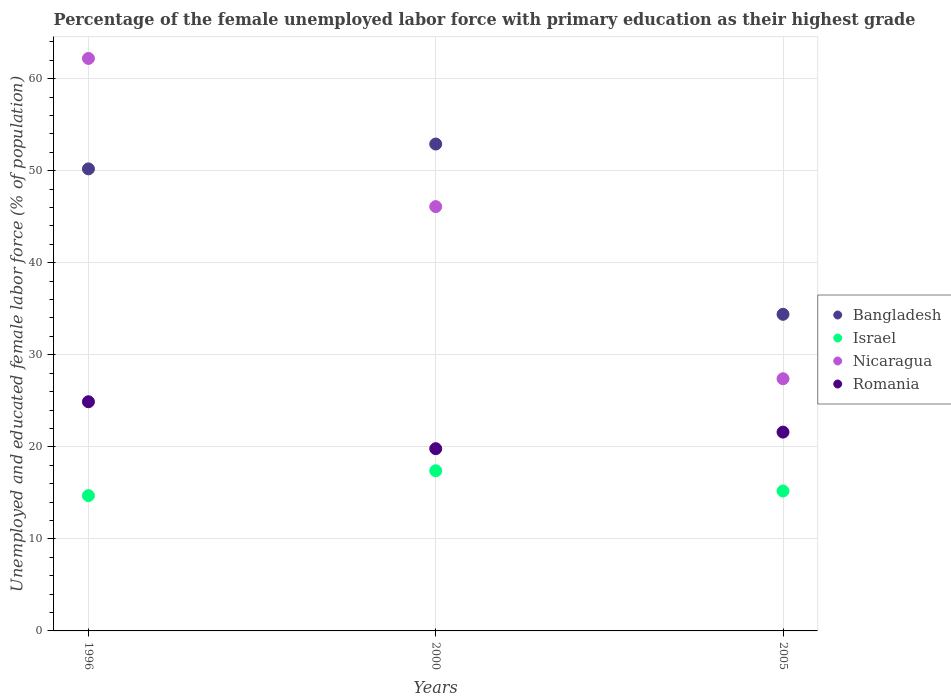Is the number of dotlines equal to the number of legend labels?
Offer a terse response. Yes. What is the percentage of the unemployed female labor force with primary education in Romania in 2005?
Your answer should be compact. 21.6. Across all years, what is the maximum percentage of the unemployed female labor force with primary education in Nicaragua?
Ensure brevity in your answer.  62.2. Across all years, what is the minimum percentage of the unemployed female labor force with primary education in Israel?
Give a very brief answer. 14.7. In which year was the percentage of the unemployed female labor force with primary education in Romania minimum?
Your answer should be compact. 2000. What is the total percentage of the unemployed female labor force with primary education in Israel in the graph?
Your response must be concise. 47.3. What is the difference between the percentage of the unemployed female labor force with primary education in Romania in 2000 and that in 2005?
Your answer should be very brief. -1.8. What is the difference between the percentage of the unemployed female labor force with primary education in Bangladesh in 2005 and the percentage of the unemployed female labor force with primary education in Nicaragua in 1996?
Make the answer very short. -27.8. What is the average percentage of the unemployed female labor force with primary education in Nicaragua per year?
Make the answer very short. 45.23. In the year 1996, what is the difference between the percentage of the unemployed female labor force with primary education in Israel and percentage of the unemployed female labor force with primary education in Romania?
Give a very brief answer. -10.2. What is the ratio of the percentage of the unemployed female labor force with primary education in Romania in 1996 to that in 2000?
Provide a succinct answer. 1.26. Is the percentage of the unemployed female labor force with primary education in Israel in 2000 less than that in 2005?
Your response must be concise. No. What is the difference between the highest and the second highest percentage of the unemployed female labor force with primary education in Bangladesh?
Give a very brief answer. 2.7. What is the difference between the highest and the lowest percentage of the unemployed female labor force with primary education in Israel?
Offer a terse response. 2.7. Is the sum of the percentage of the unemployed female labor force with primary education in Romania in 2000 and 2005 greater than the maximum percentage of the unemployed female labor force with primary education in Bangladesh across all years?
Make the answer very short. No. Is it the case that in every year, the sum of the percentage of the unemployed female labor force with primary education in Romania and percentage of the unemployed female labor force with primary education in Israel  is greater than the sum of percentage of the unemployed female labor force with primary education in Nicaragua and percentage of the unemployed female labor force with primary education in Bangladesh?
Offer a terse response. No. Is it the case that in every year, the sum of the percentage of the unemployed female labor force with primary education in Romania and percentage of the unemployed female labor force with primary education in Bangladesh  is greater than the percentage of the unemployed female labor force with primary education in Israel?
Provide a succinct answer. Yes. Is the percentage of the unemployed female labor force with primary education in Nicaragua strictly greater than the percentage of the unemployed female labor force with primary education in Romania over the years?
Give a very brief answer. Yes. Is the percentage of the unemployed female labor force with primary education in Bangladesh strictly less than the percentage of the unemployed female labor force with primary education in Israel over the years?
Give a very brief answer. No. What is the difference between two consecutive major ticks on the Y-axis?
Your answer should be very brief. 10. Does the graph contain grids?
Your response must be concise. Yes. Where does the legend appear in the graph?
Provide a succinct answer. Center right. How many legend labels are there?
Ensure brevity in your answer.  4. How are the legend labels stacked?
Offer a terse response. Vertical. What is the title of the graph?
Provide a succinct answer. Percentage of the female unemployed labor force with primary education as their highest grade. Does "Cyprus" appear as one of the legend labels in the graph?
Offer a very short reply. No. What is the label or title of the X-axis?
Your response must be concise. Years. What is the label or title of the Y-axis?
Your answer should be compact. Unemployed and educated female labor force (% of population). What is the Unemployed and educated female labor force (% of population) in Bangladesh in 1996?
Your answer should be compact. 50.2. What is the Unemployed and educated female labor force (% of population) of Israel in 1996?
Provide a succinct answer. 14.7. What is the Unemployed and educated female labor force (% of population) in Nicaragua in 1996?
Make the answer very short. 62.2. What is the Unemployed and educated female labor force (% of population) of Romania in 1996?
Keep it short and to the point. 24.9. What is the Unemployed and educated female labor force (% of population) in Bangladesh in 2000?
Your answer should be compact. 52.9. What is the Unemployed and educated female labor force (% of population) in Israel in 2000?
Provide a succinct answer. 17.4. What is the Unemployed and educated female labor force (% of population) in Nicaragua in 2000?
Your answer should be compact. 46.1. What is the Unemployed and educated female labor force (% of population) of Romania in 2000?
Give a very brief answer. 19.8. What is the Unemployed and educated female labor force (% of population) in Bangladesh in 2005?
Keep it short and to the point. 34.4. What is the Unemployed and educated female labor force (% of population) in Israel in 2005?
Provide a short and direct response. 15.2. What is the Unemployed and educated female labor force (% of population) of Nicaragua in 2005?
Your answer should be very brief. 27.4. What is the Unemployed and educated female labor force (% of population) of Romania in 2005?
Make the answer very short. 21.6. Across all years, what is the maximum Unemployed and educated female labor force (% of population) of Bangladesh?
Offer a terse response. 52.9. Across all years, what is the maximum Unemployed and educated female labor force (% of population) in Israel?
Make the answer very short. 17.4. Across all years, what is the maximum Unemployed and educated female labor force (% of population) of Nicaragua?
Your response must be concise. 62.2. Across all years, what is the maximum Unemployed and educated female labor force (% of population) of Romania?
Ensure brevity in your answer.  24.9. Across all years, what is the minimum Unemployed and educated female labor force (% of population) in Bangladesh?
Make the answer very short. 34.4. Across all years, what is the minimum Unemployed and educated female labor force (% of population) of Israel?
Your response must be concise. 14.7. Across all years, what is the minimum Unemployed and educated female labor force (% of population) of Nicaragua?
Keep it short and to the point. 27.4. Across all years, what is the minimum Unemployed and educated female labor force (% of population) in Romania?
Keep it short and to the point. 19.8. What is the total Unemployed and educated female labor force (% of population) of Bangladesh in the graph?
Make the answer very short. 137.5. What is the total Unemployed and educated female labor force (% of population) of Israel in the graph?
Your answer should be very brief. 47.3. What is the total Unemployed and educated female labor force (% of population) of Nicaragua in the graph?
Your answer should be very brief. 135.7. What is the total Unemployed and educated female labor force (% of population) of Romania in the graph?
Make the answer very short. 66.3. What is the difference between the Unemployed and educated female labor force (% of population) of Romania in 1996 and that in 2000?
Make the answer very short. 5.1. What is the difference between the Unemployed and educated female labor force (% of population) of Bangladesh in 1996 and that in 2005?
Your answer should be compact. 15.8. What is the difference between the Unemployed and educated female labor force (% of population) in Israel in 1996 and that in 2005?
Your answer should be compact. -0.5. What is the difference between the Unemployed and educated female labor force (% of population) in Nicaragua in 1996 and that in 2005?
Your answer should be compact. 34.8. What is the difference between the Unemployed and educated female labor force (% of population) of Romania in 1996 and that in 2005?
Provide a succinct answer. 3.3. What is the difference between the Unemployed and educated female labor force (% of population) in Bangladesh in 2000 and that in 2005?
Provide a succinct answer. 18.5. What is the difference between the Unemployed and educated female labor force (% of population) in Nicaragua in 2000 and that in 2005?
Your response must be concise. 18.7. What is the difference between the Unemployed and educated female labor force (% of population) of Romania in 2000 and that in 2005?
Your answer should be very brief. -1.8. What is the difference between the Unemployed and educated female labor force (% of population) of Bangladesh in 1996 and the Unemployed and educated female labor force (% of population) of Israel in 2000?
Offer a very short reply. 32.8. What is the difference between the Unemployed and educated female labor force (% of population) in Bangladesh in 1996 and the Unemployed and educated female labor force (% of population) in Nicaragua in 2000?
Keep it short and to the point. 4.1. What is the difference between the Unemployed and educated female labor force (% of population) of Bangladesh in 1996 and the Unemployed and educated female labor force (% of population) of Romania in 2000?
Your answer should be compact. 30.4. What is the difference between the Unemployed and educated female labor force (% of population) in Israel in 1996 and the Unemployed and educated female labor force (% of population) in Nicaragua in 2000?
Ensure brevity in your answer.  -31.4. What is the difference between the Unemployed and educated female labor force (% of population) of Nicaragua in 1996 and the Unemployed and educated female labor force (% of population) of Romania in 2000?
Offer a very short reply. 42.4. What is the difference between the Unemployed and educated female labor force (% of population) of Bangladesh in 1996 and the Unemployed and educated female labor force (% of population) of Nicaragua in 2005?
Keep it short and to the point. 22.8. What is the difference between the Unemployed and educated female labor force (% of population) of Bangladesh in 1996 and the Unemployed and educated female labor force (% of population) of Romania in 2005?
Ensure brevity in your answer.  28.6. What is the difference between the Unemployed and educated female labor force (% of population) of Israel in 1996 and the Unemployed and educated female labor force (% of population) of Nicaragua in 2005?
Your response must be concise. -12.7. What is the difference between the Unemployed and educated female labor force (% of population) in Nicaragua in 1996 and the Unemployed and educated female labor force (% of population) in Romania in 2005?
Offer a terse response. 40.6. What is the difference between the Unemployed and educated female labor force (% of population) in Bangladesh in 2000 and the Unemployed and educated female labor force (% of population) in Israel in 2005?
Offer a very short reply. 37.7. What is the difference between the Unemployed and educated female labor force (% of population) of Bangladesh in 2000 and the Unemployed and educated female labor force (% of population) of Nicaragua in 2005?
Make the answer very short. 25.5. What is the difference between the Unemployed and educated female labor force (% of population) in Bangladesh in 2000 and the Unemployed and educated female labor force (% of population) in Romania in 2005?
Ensure brevity in your answer.  31.3. What is the difference between the Unemployed and educated female labor force (% of population) of Israel in 2000 and the Unemployed and educated female labor force (% of population) of Nicaragua in 2005?
Provide a short and direct response. -10. What is the average Unemployed and educated female labor force (% of population) of Bangladesh per year?
Keep it short and to the point. 45.83. What is the average Unemployed and educated female labor force (% of population) of Israel per year?
Your answer should be compact. 15.77. What is the average Unemployed and educated female labor force (% of population) in Nicaragua per year?
Your answer should be very brief. 45.23. What is the average Unemployed and educated female labor force (% of population) in Romania per year?
Keep it short and to the point. 22.1. In the year 1996, what is the difference between the Unemployed and educated female labor force (% of population) in Bangladesh and Unemployed and educated female labor force (% of population) in Israel?
Provide a short and direct response. 35.5. In the year 1996, what is the difference between the Unemployed and educated female labor force (% of population) of Bangladesh and Unemployed and educated female labor force (% of population) of Romania?
Your answer should be very brief. 25.3. In the year 1996, what is the difference between the Unemployed and educated female labor force (% of population) in Israel and Unemployed and educated female labor force (% of population) in Nicaragua?
Keep it short and to the point. -47.5. In the year 1996, what is the difference between the Unemployed and educated female labor force (% of population) in Israel and Unemployed and educated female labor force (% of population) in Romania?
Offer a very short reply. -10.2. In the year 1996, what is the difference between the Unemployed and educated female labor force (% of population) of Nicaragua and Unemployed and educated female labor force (% of population) of Romania?
Keep it short and to the point. 37.3. In the year 2000, what is the difference between the Unemployed and educated female labor force (% of population) in Bangladesh and Unemployed and educated female labor force (% of population) in Israel?
Ensure brevity in your answer.  35.5. In the year 2000, what is the difference between the Unemployed and educated female labor force (% of population) of Bangladesh and Unemployed and educated female labor force (% of population) of Nicaragua?
Ensure brevity in your answer.  6.8. In the year 2000, what is the difference between the Unemployed and educated female labor force (% of population) of Bangladesh and Unemployed and educated female labor force (% of population) of Romania?
Make the answer very short. 33.1. In the year 2000, what is the difference between the Unemployed and educated female labor force (% of population) in Israel and Unemployed and educated female labor force (% of population) in Nicaragua?
Keep it short and to the point. -28.7. In the year 2000, what is the difference between the Unemployed and educated female labor force (% of population) in Nicaragua and Unemployed and educated female labor force (% of population) in Romania?
Provide a short and direct response. 26.3. In the year 2005, what is the difference between the Unemployed and educated female labor force (% of population) in Israel and Unemployed and educated female labor force (% of population) in Nicaragua?
Provide a succinct answer. -12.2. In the year 2005, what is the difference between the Unemployed and educated female labor force (% of population) in Israel and Unemployed and educated female labor force (% of population) in Romania?
Give a very brief answer. -6.4. What is the ratio of the Unemployed and educated female labor force (% of population) of Bangladesh in 1996 to that in 2000?
Offer a terse response. 0.95. What is the ratio of the Unemployed and educated female labor force (% of population) of Israel in 1996 to that in 2000?
Provide a short and direct response. 0.84. What is the ratio of the Unemployed and educated female labor force (% of population) in Nicaragua in 1996 to that in 2000?
Ensure brevity in your answer.  1.35. What is the ratio of the Unemployed and educated female labor force (% of population) of Romania in 1996 to that in 2000?
Provide a short and direct response. 1.26. What is the ratio of the Unemployed and educated female labor force (% of population) in Bangladesh in 1996 to that in 2005?
Offer a terse response. 1.46. What is the ratio of the Unemployed and educated female labor force (% of population) in Israel in 1996 to that in 2005?
Ensure brevity in your answer.  0.97. What is the ratio of the Unemployed and educated female labor force (% of population) in Nicaragua in 1996 to that in 2005?
Your answer should be compact. 2.27. What is the ratio of the Unemployed and educated female labor force (% of population) in Romania in 1996 to that in 2005?
Provide a short and direct response. 1.15. What is the ratio of the Unemployed and educated female labor force (% of population) in Bangladesh in 2000 to that in 2005?
Keep it short and to the point. 1.54. What is the ratio of the Unemployed and educated female labor force (% of population) of Israel in 2000 to that in 2005?
Your response must be concise. 1.14. What is the ratio of the Unemployed and educated female labor force (% of population) in Nicaragua in 2000 to that in 2005?
Your response must be concise. 1.68. What is the ratio of the Unemployed and educated female labor force (% of population) of Romania in 2000 to that in 2005?
Offer a terse response. 0.92. What is the difference between the highest and the second highest Unemployed and educated female labor force (% of population) in Nicaragua?
Ensure brevity in your answer.  16.1. What is the difference between the highest and the second highest Unemployed and educated female labor force (% of population) in Romania?
Make the answer very short. 3.3. What is the difference between the highest and the lowest Unemployed and educated female labor force (% of population) in Bangladesh?
Give a very brief answer. 18.5. What is the difference between the highest and the lowest Unemployed and educated female labor force (% of population) in Nicaragua?
Your response must be concise. 34.8. What is the difference between the highest and the lowest Unemployed and educated female labor force (% of population) of Romania?
Your response must be concise. 5.1. 